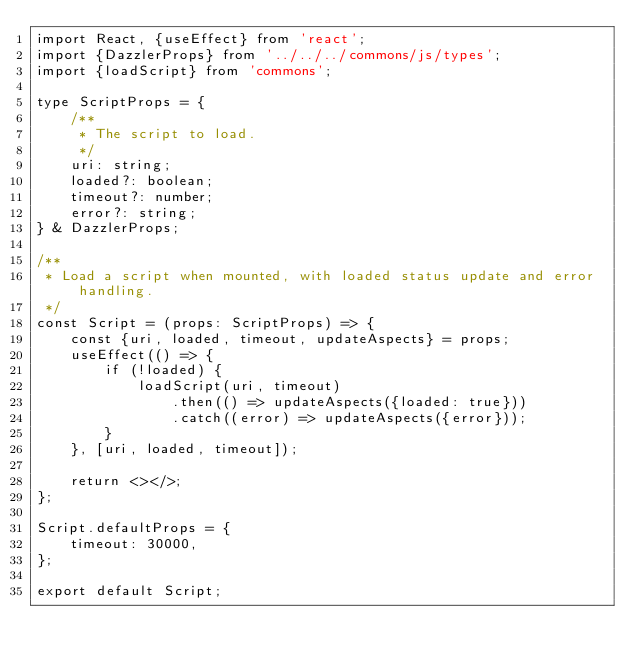<code> <loc_0><loc_0><loc_500><loc_500><_TypeScript_>import React, {useEffect} from 'react';
import {DazzlerProps} from '../../../commons/js/types';
import {loadScript} from 'commons';

type ScriptProps = {
    /**
     * The script to load.
     */
    uri: string;
    loaded?: boolean;
    timeout?: number;
    error?: string;
} & DazzlerProps;

/**
 * Load a script when mounted, with loaded status update and error handling.
 */
const Script = (props: ScriptProps) => {
    const {uri, loaded, timeout, updateAspects} = props;
    useEffect(() => {
        if (!loaded) {
            loadScript(uri, timeout)
                .then(() => updateAspects({loaded: true}))
                .catch((error) => updateAspects({error}));
        }
    }, [uri, loaded, timeout]);

    return <></>;
};

Script.defaultProps = {
    timeout: 30000,
};

export default Script;
</code> 